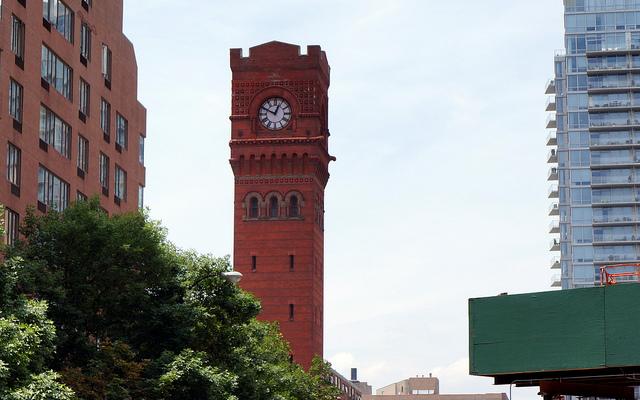How many arched windows under the clock?
Short answer required. 3. Is the time correct?
Keep it brief. Yes. Is this clock tower functional?
Write a very short answer. Yes. 